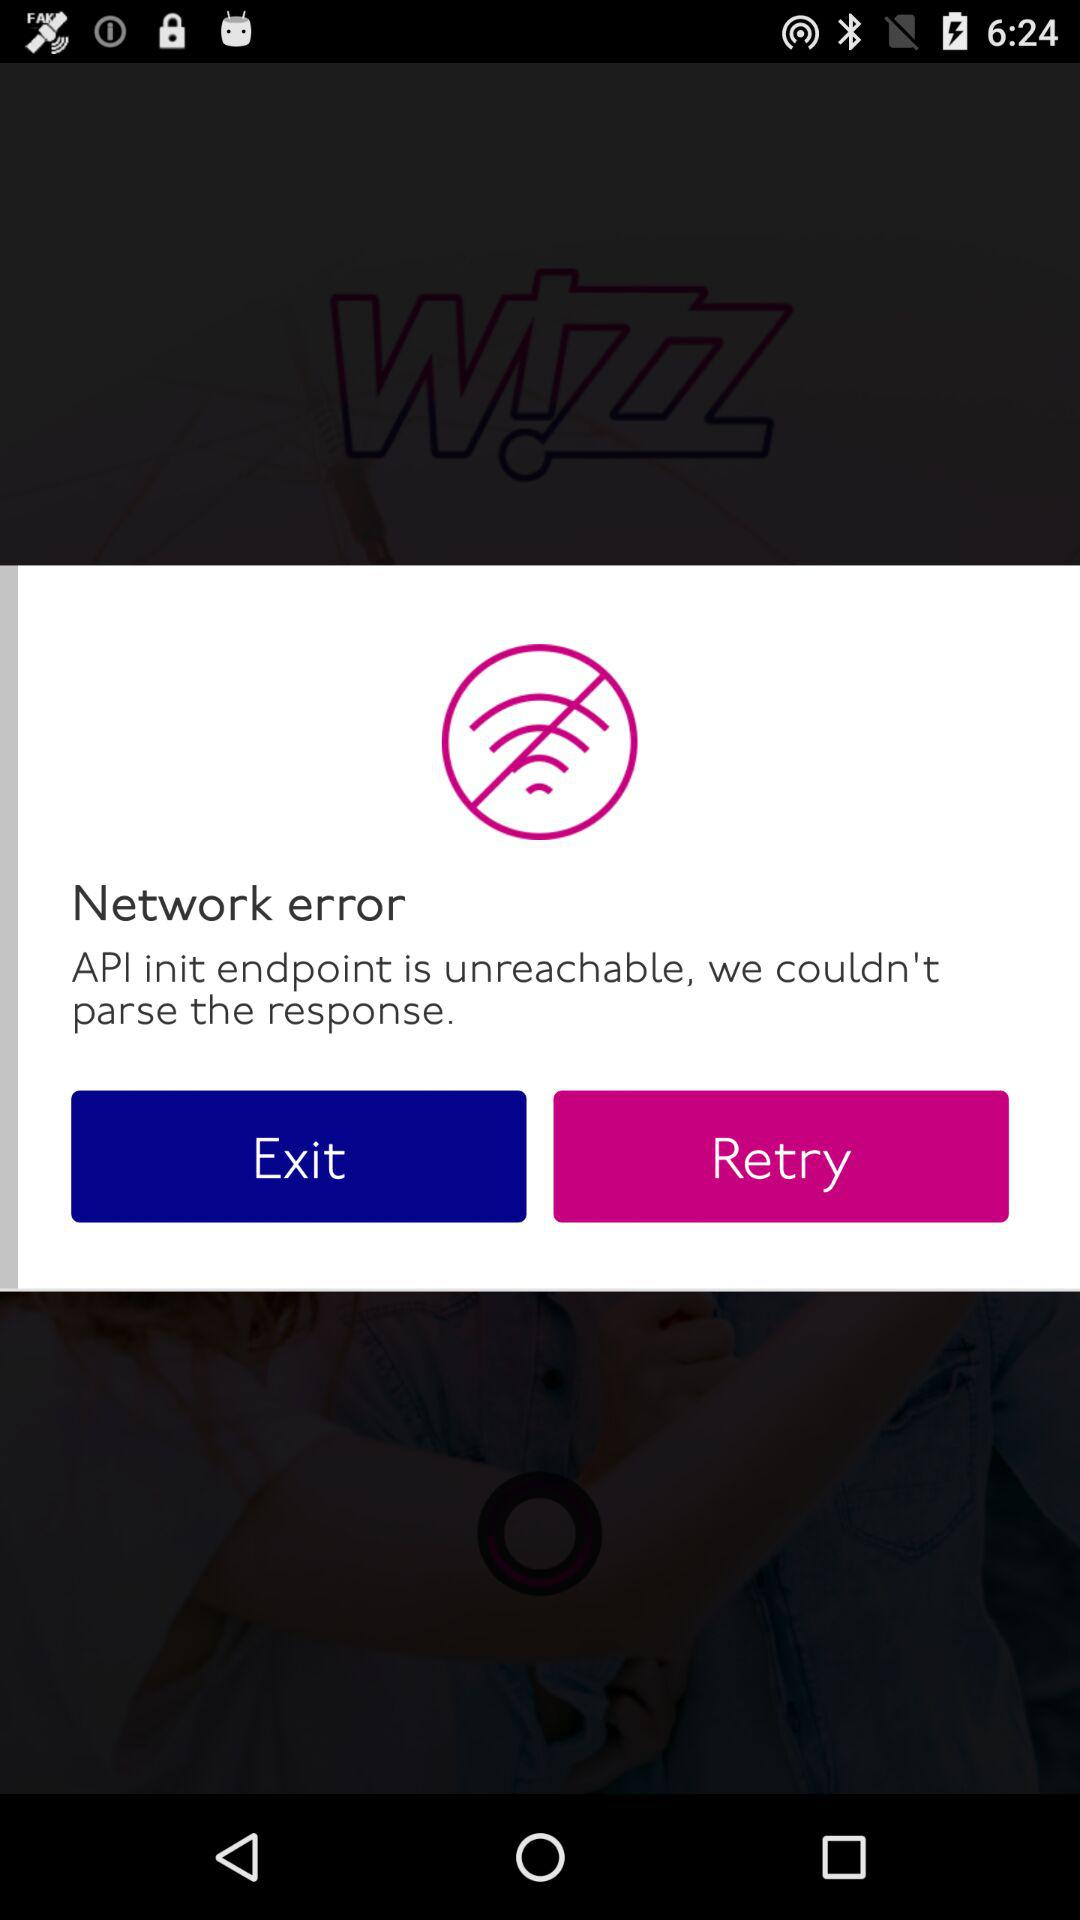What is the name of the application? The name of the application is "Wizz Air". 